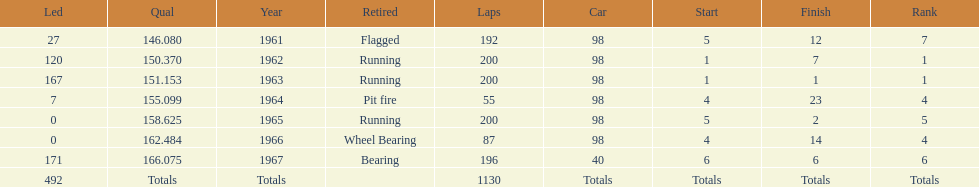Number of times to finish the races running. 3. 